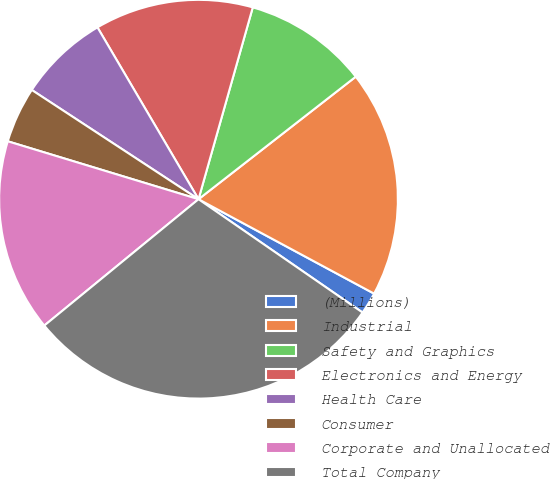Convert chart to OTSL. <chart><loc_0><loc_0><loc_500><loc_500><pie_chart><fcel>(Millions)<fcel>Industrial<fcel>Safety and Graphics<fcel>Electronics and Energy<fcel>Health Care<fcel>Consumer<fcel>Corporate and Unallocated<fcel>Total Company<nl><fcel>1.77%<fcel>18.39%<fcel>10.08%<fcel>12.85%<fcel>7.31%<fcel>4.54%<fcel>15.62%<fcel>29.46%<nl></chart> 